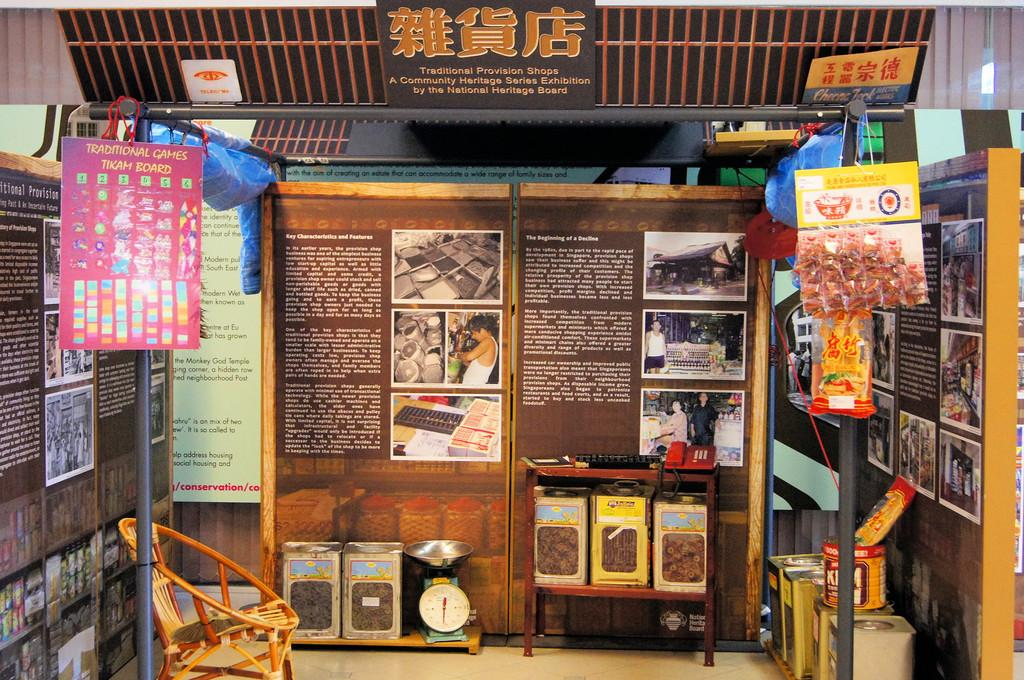<image>
Summarize the visual content of the image. A street shop with a sign reading about the beginning of decline. 